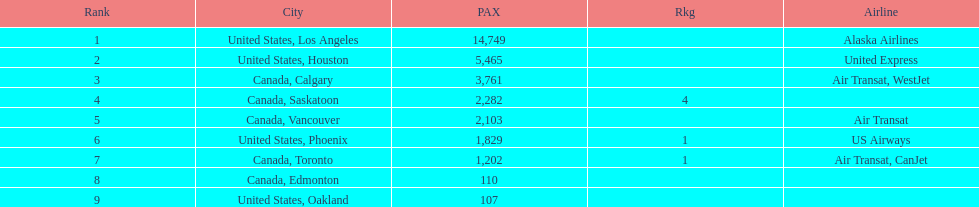Was los angeles or houston the busiest international route at manzanillo international airport in 2013? Los Angeles. 